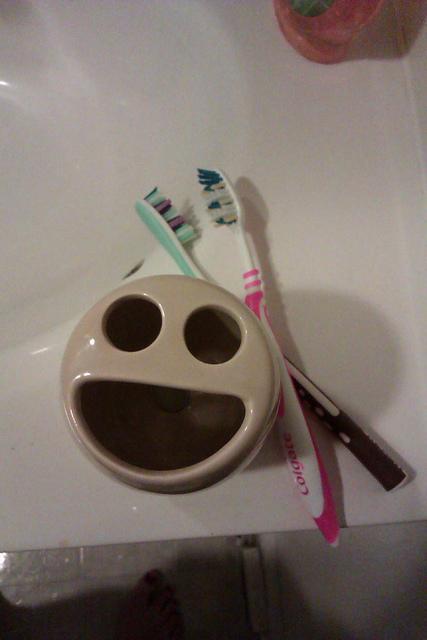What is the purpose of the cup? Please explain your reasoning. is novelty. The cup has holes for the brushes. 